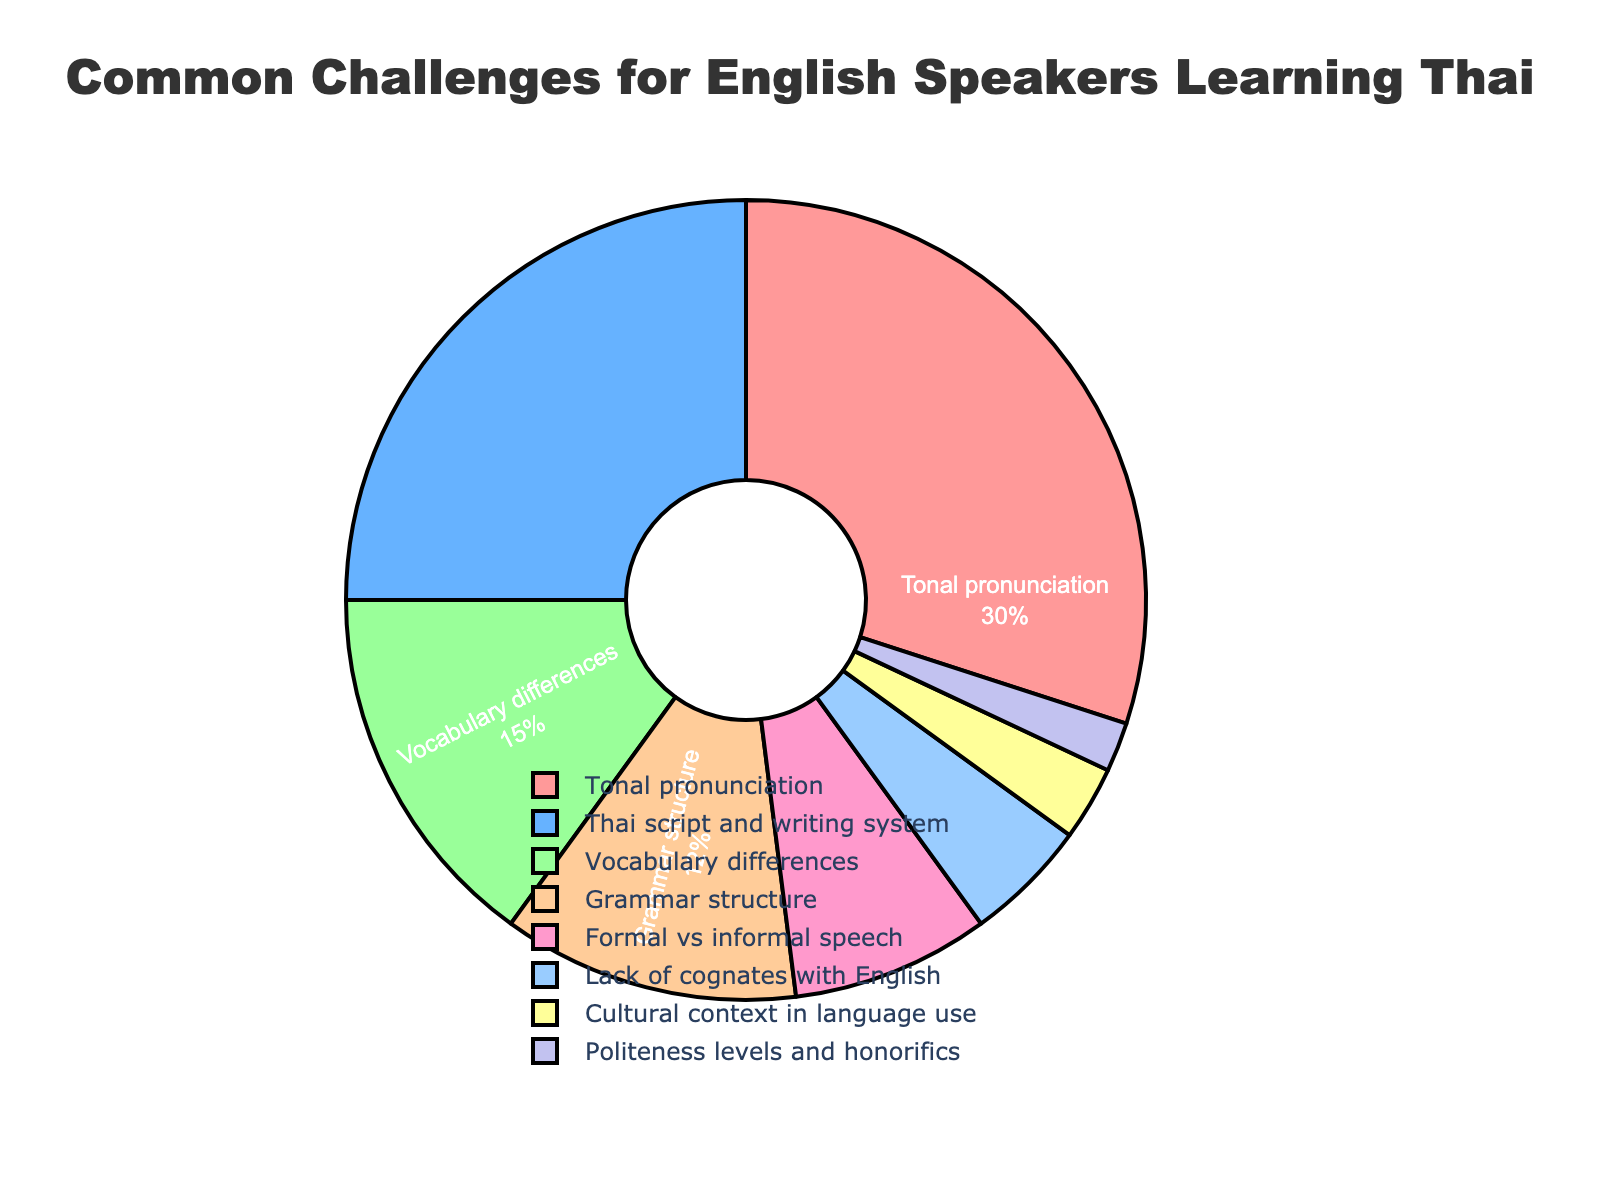What is the most common challenge faced by English speakers when learning Thai? The pie chart shows a clear breakdown of challenges; the segment representing "Tonal pronunciation" is the largest.
Answer: Tonal pronunciation What is the combined percentage of challenges related to the script and writing system and vocabulary differences? Add the percentages for "Thai script and writing system" (25%) and "Vocabulary differences" (15%). Therefore, 25 + 15 = 40%.
Answer: 40% Which challenge is represented by the green segment in the pie chart? By observing the green segment in the pie chart and matching it with the legend, the green segment corresponds to "Vocabulary differences".
Answer: Vocabulary differences Which is more challenging for English speakers: grammar structure or politeness levels and honorifics? Compare the percentages for "Grammar structure" (12%) and "Politeness levels and honorifics" (2%). Since 12% is greater than 2%, grammar structure is more challenging.
Answer: Grammar structure Which challenge has the smallest percentage, and what is that percentage? The challenge with the smallest percentage can be identified by looking for the smallest segment in the pie chart, which corresponds to "Politeness levels and honorifics" with 2%.
Answer: Politeness levels and honorifics, 2% By how much is the percentage of "Tonal pronunciation" higher than "Cultural context in language use"? Subtract the percentage of "Cultural context in language use" (3%) from "Tonal pronunciation" (30%). Thus, 30 - 3 = 27%.
Answer: 27% Are the combined challenges of "Thai script and writing system" and "Grammar structure" more or less than the "Tonal pronunciation" challenge alone? Add the percentages of "Thai script and writing system" (25%) and "Grammar structure" (12%), which equals 37%. Compare this to "Tonal pronunciation" (30%). Since 37% is greater than 30%, it is more.
Answer: More What percentage of challenges are due to formal vs informal speech and lack of cognates with English combined? Add the percentages for "Formal vs informal speech" (8%) and "Lack of cognates with English" (5%). Therefore, 8 + 5 = 13%.
Answer: 13% How much more common is "Thai script and writing system" as a challenge compared to "Formal vs informal speech"? Subtract the percentage for "Formal vs informal speech" (8%) from "Thai script and writing system" (25%). Therefore, 25 - 8 = 17%.
Answer: 17% What is the second most common challenge after "Tonal pronunciation"? By examining the pie chart, the second largest segment represents "Thai script and writing system" at 25%.
Answer: Thai script and writing system 